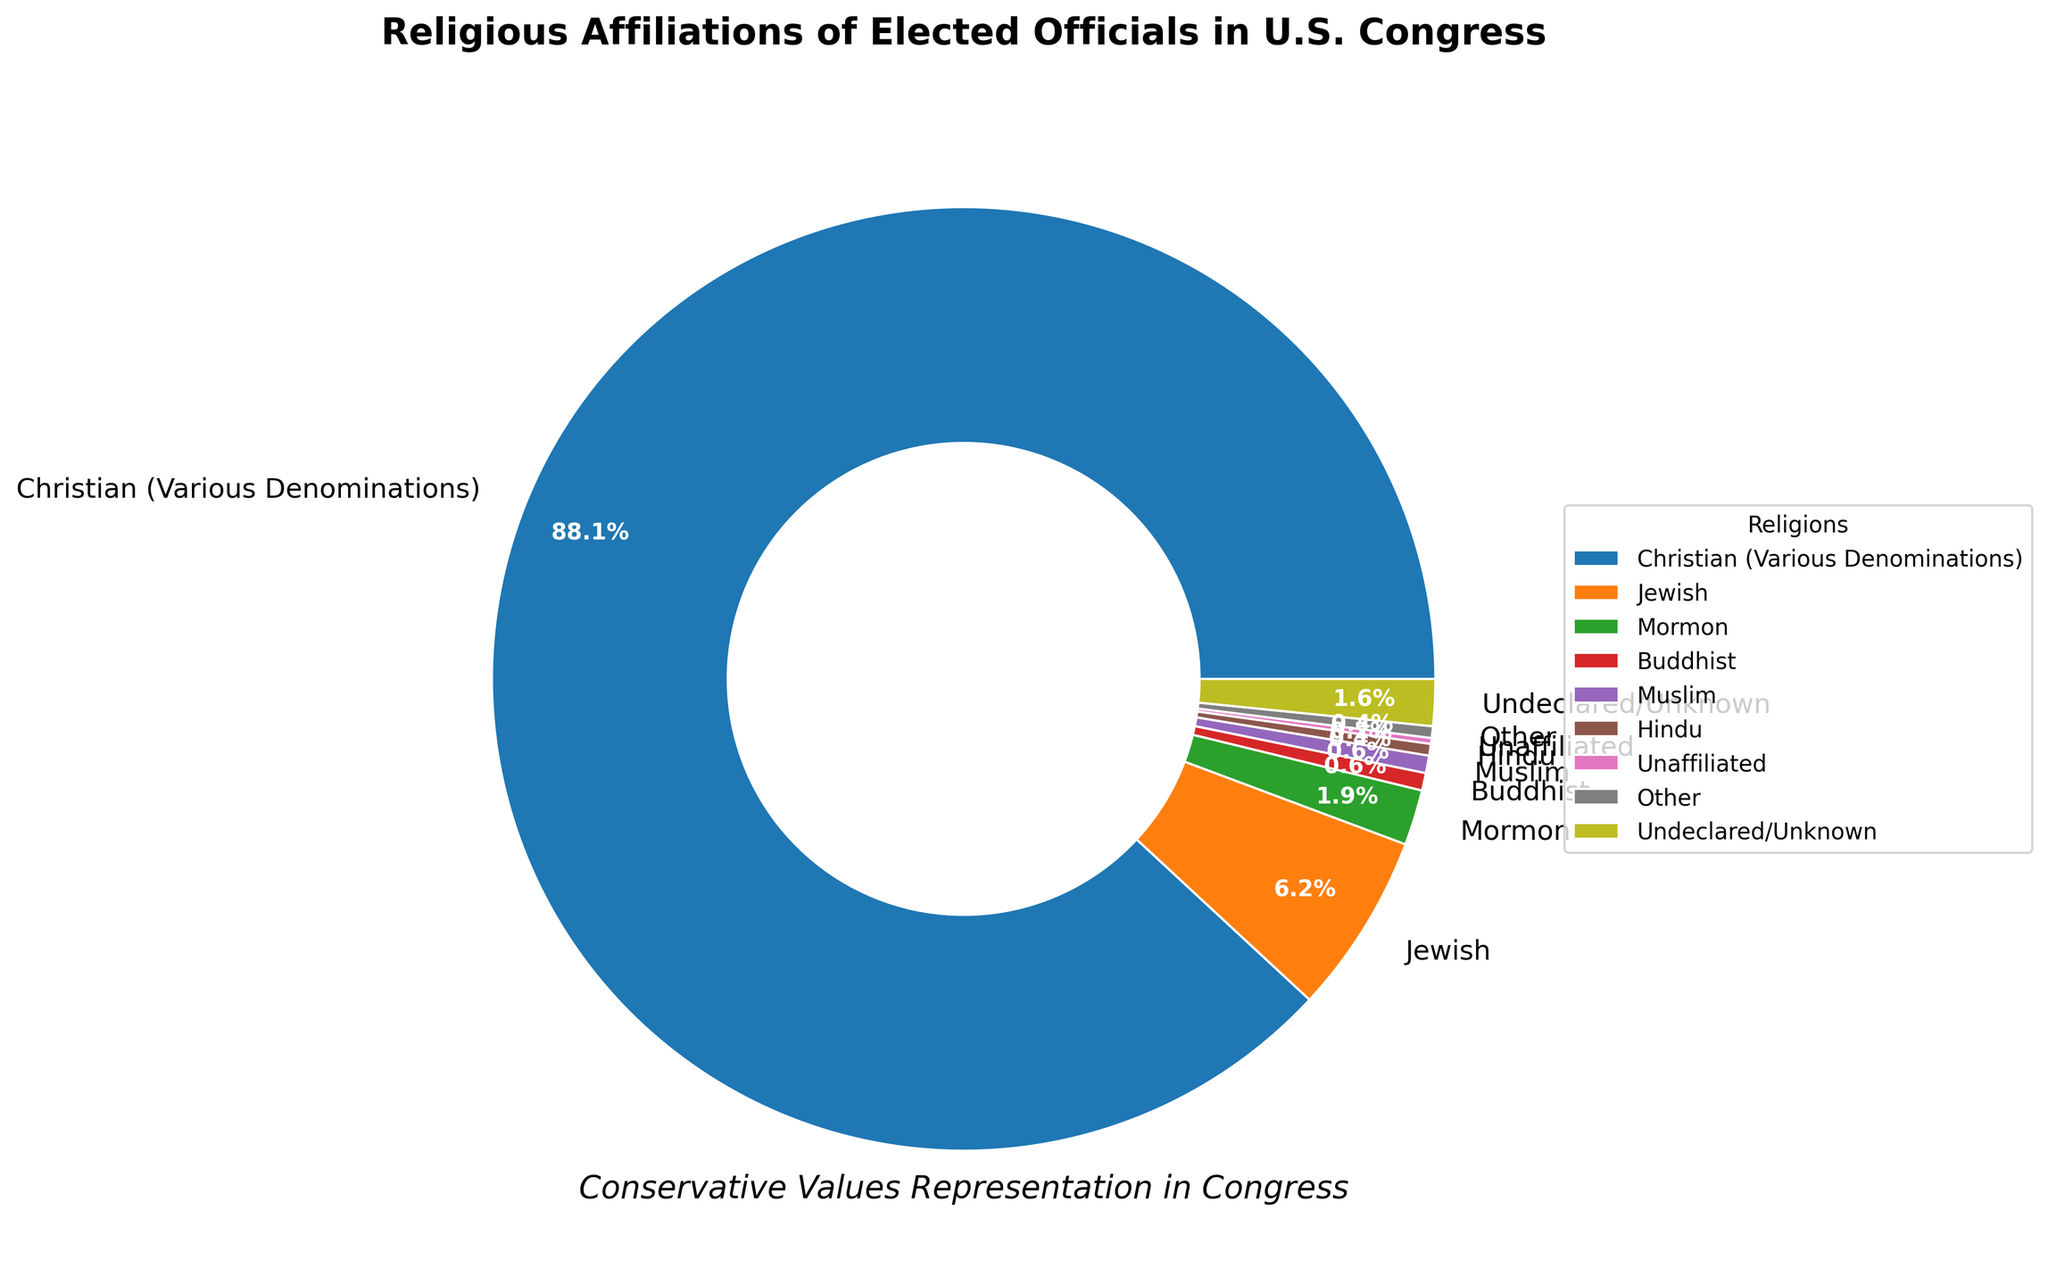what is the percentage of elected officials who are Jewish and Hindu combined? To find the combined percentage of Jewish and Hindu officials, sum their individual percentages. From the data, Jewish officials make up 6.2% and Hindu officials make up 0.4%. So, combined, they represent 6.2% + 0.4% = 6.6%.
Answer: 6.6% Which religion has the lowest representation among elected officials, and what is the percentage? From the data, the religion with the lowest representation is Unaffiliated with 0.2%.
Answer: Unaffiliated, 0.2% How much higher is the percentage of Christian officials compared to all non-Christian officials in total? First, calculate the total percentage of non-Christian officials by summing the percentages of all non-Christian groups: 6.2 (Jewish) + 1.9 (Mormon) + 0.6 (Buddhist) + 0.6 (Muslim) + 0.4 (Hindu) + 0.2 (Unaffiliated) + 0.4 (Other) + 1.6 (Undeclared/Unknown) = 11.4%. The percentage of Christian officials is 88.1%. The difference is 88.1% - 11.4% = 76.7%.
Answer: 76.7% Which two groups have the closest percentages of representation, and what are these percentages? By scanning the percentages of all groups, it is clear that Buddhists and Muslims both have a percentage of 0.6%.
Answer: Buddhists and Muslims, 0.6% What is the combined percentage of groups with less than 1% representation? Sum the percentages of the groups with less than 1% representation: 0.6 (Buddhist) + 0.6 (Muslim) + 0.4 (Hindu) + 0.2 (Unaffiliated) + 0.4 (Other) = 2.2%.
Answer: 2.2% What is the second-largest religious affiliation among the elected officials and its percentage? From the data, the second-largest religious affiliation after Christian is Jewish, with a percentage of 6.2%.
Answer: Jewish, 6.2% Is the percentage of Mormon officials greater or less than that of Unaffiliated officials? By how much? The percentage of Mormon officials is 1.9% and that of Unaffiliated officials is 0.2%. The Mormons have a greater representation by 1.9% - 0.2% = 1.7%.
Answer: Greater, by 1.7% Identify the group with the percentage closest to 2% and state its percentage. By examining the percentages, Mormon officials have the closest percentage to 2%, which is 1.9%.
Answer: Mormon, 1.9% What percentage of the officials have declared their religious affiliations? Subtract the percentage of Undeclared/Unknown officials from 100% to find those who declared. So, 100% - 1.6% = 98.4%.
Answer: 98.4% What is the sum of officials who are either Christian, Jewish, or Mormon? Sum the percentages for Christian, Jewish, and Mormon officials: 88.1% (Christian) + 6.2% (Jewish) + 1.9% (Mormon) = 96.2%.
Answer: 96.2% 